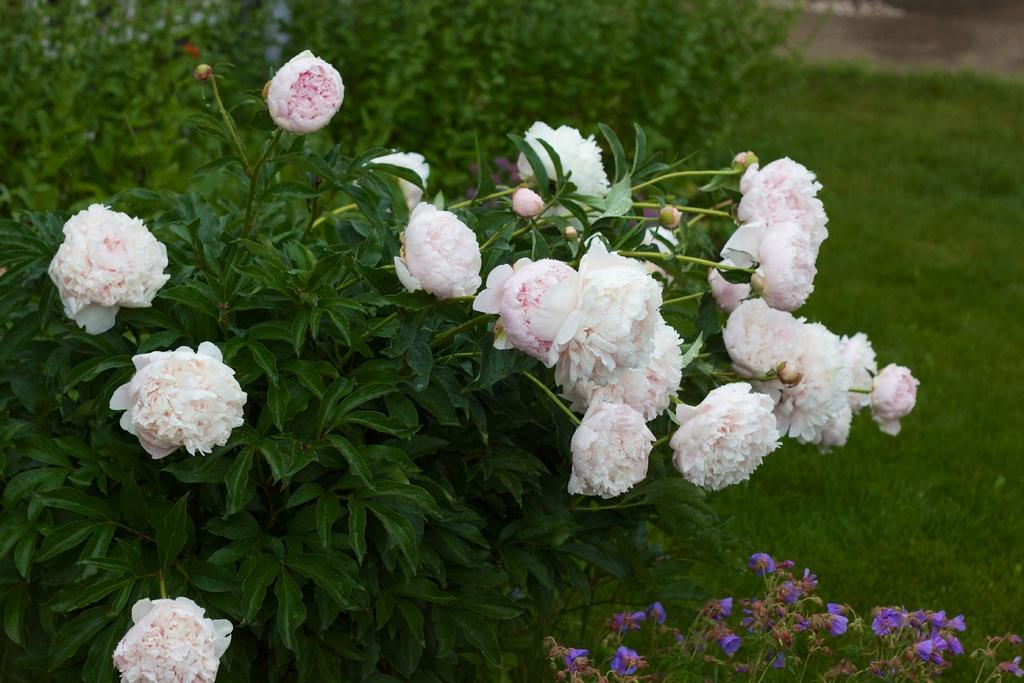What type of vegetation is present on the ground in the image? There is green grass on the ground in the image. What color are the flowers in the image? The flowers in the image are white. What other type of vegetation can be seen in the image? There are green color plants in the image. What type of liquid is being poured from the light in the image? There is no liquid or light present in the image; it only features green grass, white flowers, and green plants. 